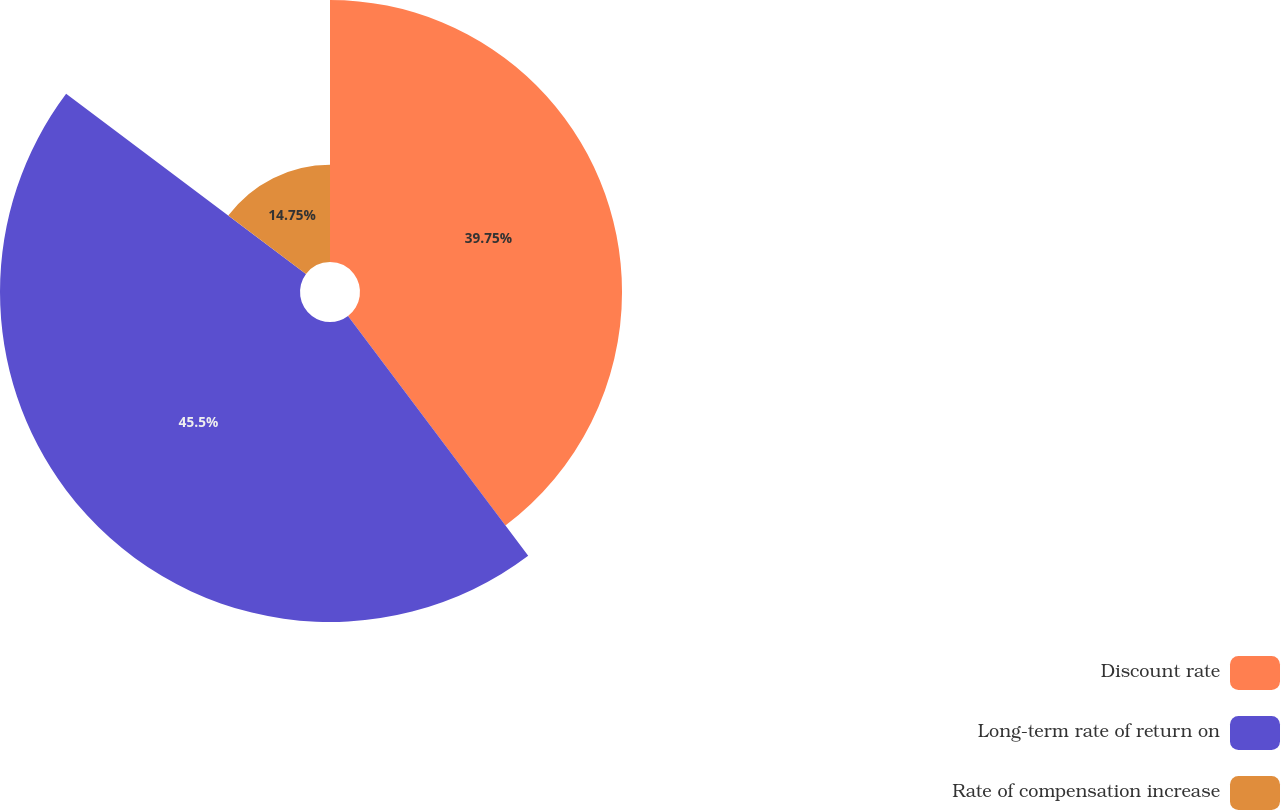Convert chart. <chart><loc_0><loc_0><loc_500><loc_500><pie_chart><fcel>Discount rate<fcel>Long-term rate of return on<fcel>Rate of compensation increase<nl><fcel>39.75%<fcel>45.51%<fcel>14.75%<nl></chart> 